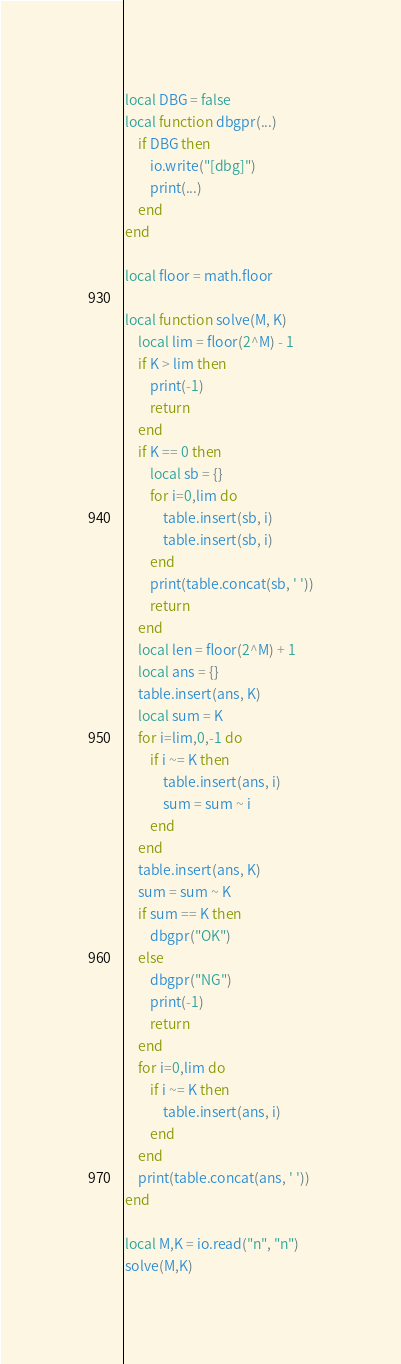Convert code to text. <code><loc_0><loc_0><loc_500><loc_500><_Lua_>local DBG = false
local function dbgpr(...)
    if DBG then
        io.write("[dbg]")
        print(...)
    end
end

local floor = math.floor

local function solve(M, K)
    local lim = floor(2^M) - 1
    if K > lim then
        print(-1)
        return
    end
    if K == 0 then
        local sb = {}
        for i=0,lim do
            table.insert(sb, i)
            table.insert(sb, i)
        end
        print(table.concat(sb, ' '))
        return
    end
    local len = floor(2^M) + 1
    local ans = {}
    table.insert(ans, K)
    local sum = K
    for i=lim,0,-1 do
        if i ~= K then
            table.insert(ans, i)
            sum = sum ~ i
        end
    end
    table.insert(ans, K)
    sum = sum ~ K
    if sum == K then
        dbgpr("OK")
    else
        dbgpr("NG")
        print(-1)
        return
    end
    for i=0,lim do
        if i ~= K then
            table.insert(ans, i)
        end
    end
    print(table.concat(ans, ' '))
end

local M,K = io.read("n", "n")
solve(M,K)
</code> 